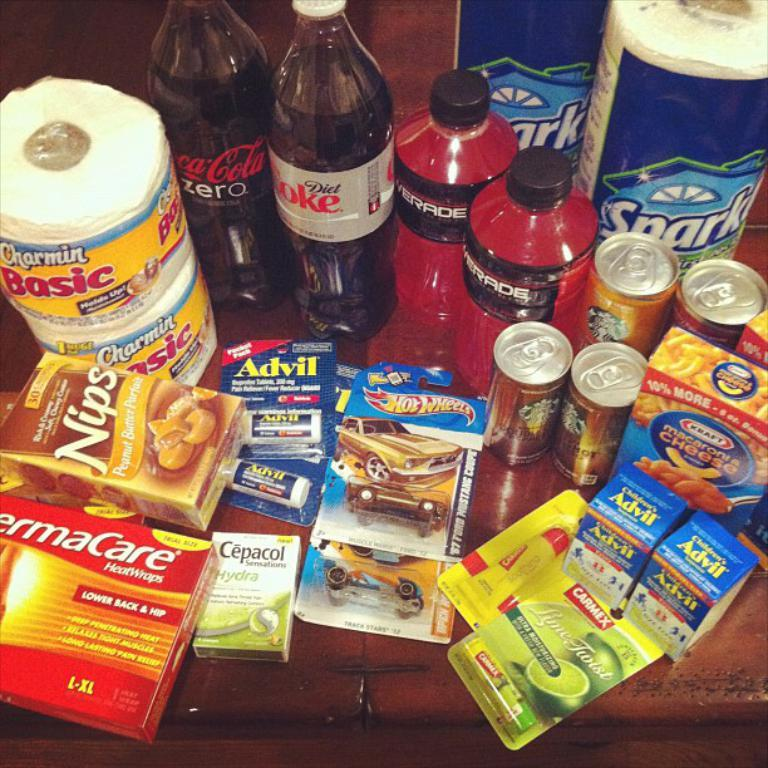Provide a one-sentence caption for the provided image. Advil, food, soda, powerade, and paper towels on a table. 